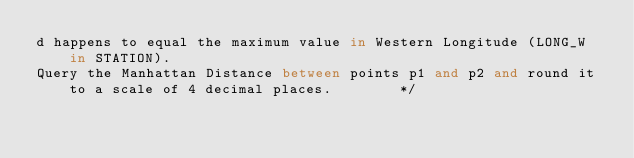Convert code to text. <code><loc_0><loc_0><loc_500><loc_500><_SQL_>d happens to equal the maximum value in Western Longitude (LONG_W in STATION).
Query the Manhattan Distance between points p1 and p2 and round it to a scale of 4 decimal places.        */</code> 